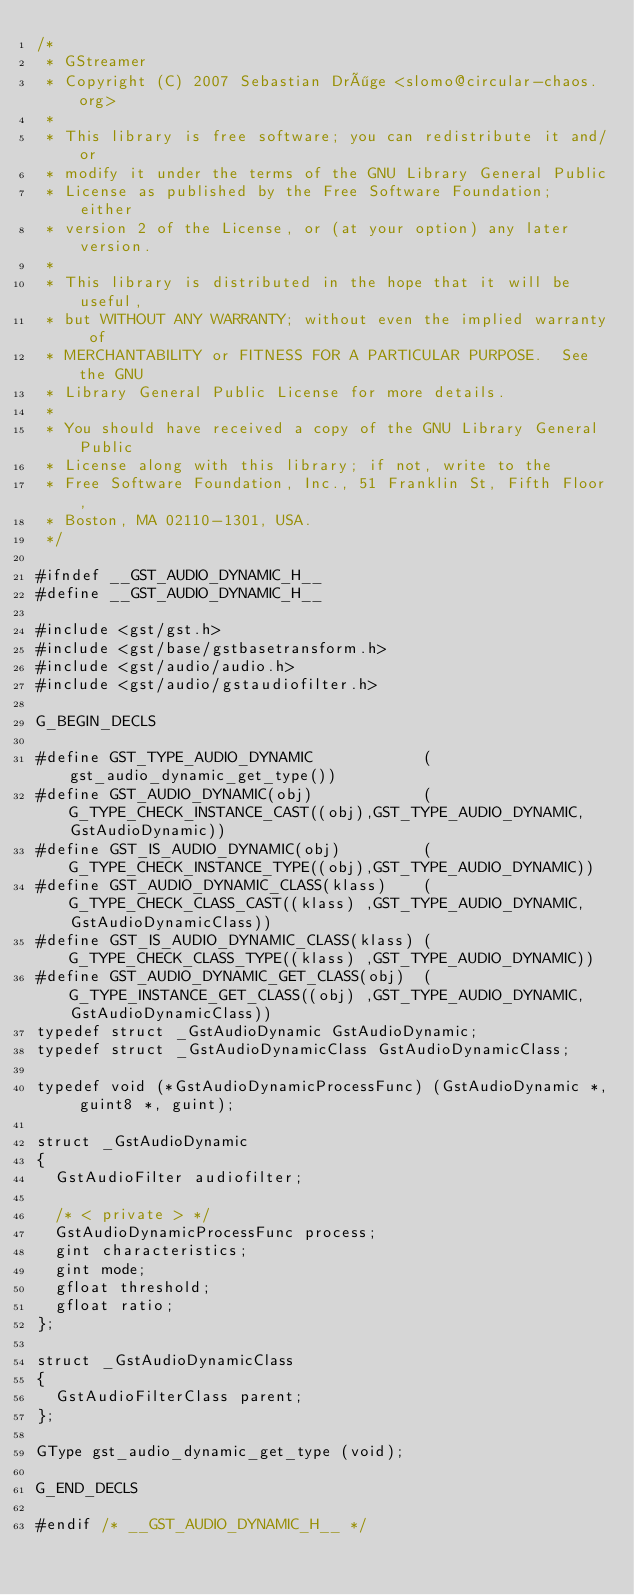Convert code to text. <code><loc_0><loc_0><loc_500><loc_500><_C_>/* 
 * GStreamer
 * Copyright (C) 2007 Sebastian Dröge <slomo@circular-chaos.org>
 *
 * This library is free software; you can redistribute it and/or
 * modify it under the terms of the GNU Library General Public
 * License as published by the Free Software Foundation; either
 * version 2 of the License, or (at your option) any later version.
 *
 * This library is distributed in the hope that it will be useful,
 * but WITHOUT ANY WARRANTY; without even the implied warranty of
 * MERCHANTABILITY or FITNESS FOR A PARTICULAR PURPOSE.  See the GNU
 * Library General Public License for more details.
 *
 * You should have received a copy of the GNU Library General Public
 * License along with this library; if not, write to the
 * Free Software Foundation, Inc., 51 Franklin St, Fifth Floor,
 * Boston, MA 02110-1301, USA.
 */

#ifndef __GST_AUDIO_DYNAMIC_H__
#define __GST_AUDIO_DYNAMIC_H__

#include <gst/gst.h>
#include <gst/base/gstbasetransform.h>
#include <gst/audio/audio.h>
#include <gst/audio/gstaudiofilter.h>

G_BEGIN_DECLS

#define GST_TYPE_AUDIO_DYNAMIC            (gst_audio_dynamic_get_type())
#define GST_AUDIO_DYNAMIC(obj)            (G_TYPE_CHECK_INSTANCE_CAST((obj),GST_TYPE_AUDIO_DYNAMIC,GstAudioDynamic))
#define GST_IS_AUDIO_DYNAMIC(obj)         (G_TYPE_CHECK_INSTANCE_TYPE((obj),GST_TYPE_AUDIO_DYNAMIC))
#define GST_AUDIO_DYNAMIC_CLASS(klass)    (G_TYPE_CHECK_CLASS_CAST((klass) ,GST_TYPE_AUDIO_DYNAMIC,GstAudioDynamicClass))
#define GST_IS_AUDIO_DYNAMIC_CLASS(klass) (G_TYPE_CHECK_CLASS_TYPE((klass) ,GST_TYPE_AUDIO_DYNAMIC))
#define GST_AUDIO_DYNAMIC_GET_CLASS(obj)  (G_TYPE_INSTANCE_GET_CLASS((obj) ,GST_TYPE_AUDIO_DYNAMIC,GstAudioDynamicClass))
typedef struct _GstAudioDynamic GstAudioDynamic;
typedef struct _GstAudioDynamicClass GstAudioDynamicClass;

typedef void (*GstAudioDynamicProcessFunc) (GstAudioDynamic *, guint8 *, guint);

struct _GstAudioDynamic
{
  GstAudioFilter audiofilter;

  /* < private > */
  GstAudioDynamicProcessFunc process;
  gint characteristics;
  gint mode;
  gfloat threshold;
  gfloat ratio;
};

struct _GstAudioDynamicClass
{
  GstAudioFilterClass parent;
};

GType gst_audio_dynamic_get_type (void);

G_END_DECLS

#endif /* __GST_AUDIO_DYNAMIC_H__ */
</code> 